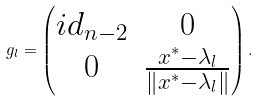<formula> <loc_0><loc_0><loc_500><loc_500>g _ { l } = \begin{pmatrix} { i d } _ { n - 2 } & 0 \\ 0 & \frac { x ^ { \ast } - \lambda _ { l } } { \| x ^ { \ast } - \lambda _ { l } \| } \end{pmatrix} .</formula> 